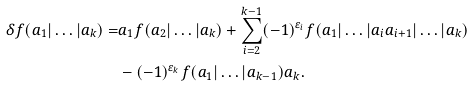Convert formula to latex. <formula><loc_0><loc_0><loc_500><loc_500>\delta f ( a _ { 1 } | \dots | a _ { k } ) = & a _ { 1 } f ( a _ { 2 } | \dots | a _ { k } ) + \sum _ { i = 2 } ^ { k - 1 } ( - 1 ) ^ { \varepsilon _ { i } } f ( a _ { 1 } | \dots | a _ { i } a _ { i + 1 } | \dots | a _ { k } ) \\ & - ( - 1 ) ^ { \varepsilon _ { k } } f ( a _ { 1 } | \dots | a _ { k - 1 } ) a _ { k } .</formula> 